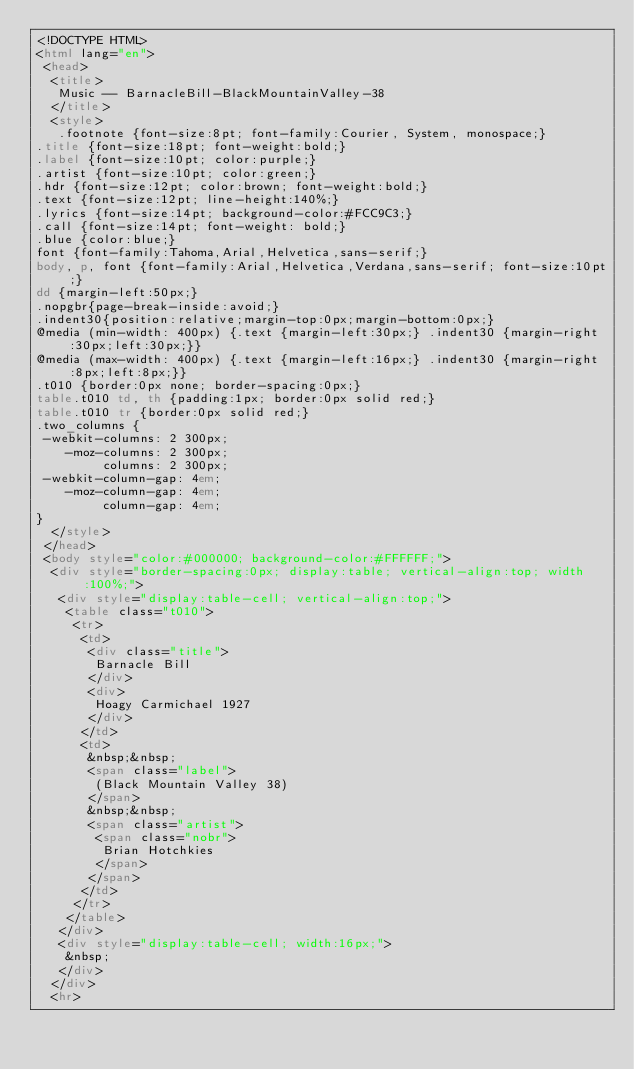<code> <loc_0><loc_0><loc_500><loc_500><_HTML_><!DOCTYPE HTML>
<html lang="en">
 <head>
  <title>
   Music -- BarnacleBill-BlackMountainValley-38
  </title>
  <style>
   .footnote {font-size:8pt; font-family:Courier, System, monospace;}
.title {font-size:18pt; font-weight:bold;}
.label {font-size:10pt; color:purple;}
.artist {font-size:10pt; color:green;}
.hdr {font-size:12pt; color:brown; font-weight:bold;}
.text {font-size:12pt; line-height:140%;}
.lyrics {font-size:14pt; background-color:#FCC9C3;}
.call {font-size:14pt; font-weight: bold;}
.blue {color:blue;}
font {font-family:Tahoma,Arial,Helvetica,sans-serif;}
body, p, font {font-family:Arial,Helvetica,Verdana,sans-serif; font-size:10pt;}
dd {margin-left:50px;}
.nopgbr{page-break-inside:avoid;}
.indent30{position:relative;margin-top:0px;margin-bottom:0px;}
@media (min-width: 400px) {.text {margin-left:30px;} .indent30 {margin-right:30px;left:30px;}}
@media (max-width: 400px) {.text {margin-left:16px;} .indent30 {margin-right:8px;left:8px;}}
.t010 {border:0px none; border-spacing:0px;}
table.t010 td, th {padding:1px; border:0px solid red;}
table.t010 tr {border:0px solid red;}
.two_columns {
 -webkit-columns: 2 300px;
    -moz-columns: 2 300px;
         columns: 2 300px;
 -webkit-column-gap: 4em;
    -moz-column-gap: 4em;
         column-gap: 4em;
}
  </style>
 </head>
 <body style="color:#000000; background-color:#FFFFFF;">
  <div style="border-spacing:0px; display:table; vertical-align:top; width:100%;">
   <div style="display:table-cell; vertical-align:top;">
    <table class="t010">
     <tr>
      <td>
       <div class="title">
        Barnacle Bill
       </div>
       <div>
        Hoagy Carmichael 1927
       </div>
      </td>
      <td>
       &nbsp;&nbsp;
       <span class="label">
        (Black Mountain Valley 38)
       </span>
       &nbsp;&nbsp;
       <span class="artist">
        <span class="nobr">
         Brian Hotchkies
        </span>
       </span>
      </td>
     </tr>
    </table>
   </div>
   <div style="display:table-cell; width:16px;">
    &nbsp;
   </div>
  </div>
  <hr></code> 